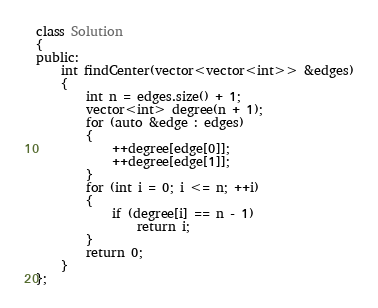Convert code to text. <code><loc_0><loc_0><loc_500><loc_500><_C++_>class Solution
{
public:
	int findCenter(vector<vector<int>> &edges)
	{
		int n = edges.size() + 1;
		vector<int> degree(n + 1);
		for (auto &edge : edges)
		{
			++degree[edge[0]];
			++degree[edge[1]];
		}
		for (int i = 0; i <= n; ++i)
		{
			if (degree[i] == n - 1)
				return i;
		}
		return 0;
	}
};</code> 